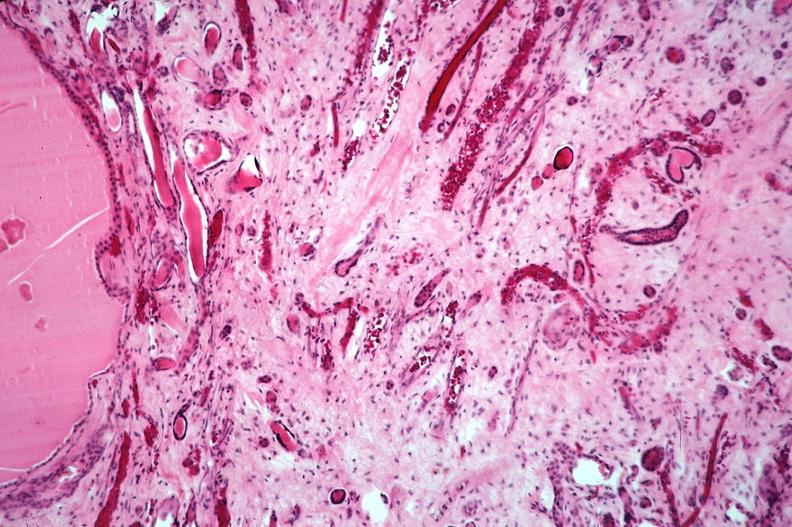where is this?
Answer the question using a single word or phrase. Urinary 